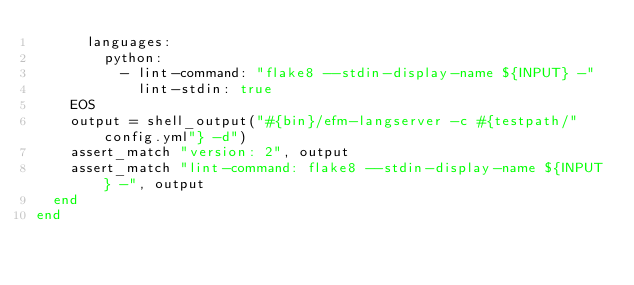<code> <loc_0><loc_0><loc_500><loc_500><_Ruby_>      languages:
        python:
          - lint-command: "flake8 --stdin-display-name ${INPUT} -"
            lint-stdin: true
    EOS
    output = shell_output("#{bin}/efm-langserver -c #{testpath/"config.yml"} -d")
    assert_match "version: 2", output
    assert_match "lint-command: flake8 --stdin-display-name ${INPUT} -", output
  end
end
</code> 